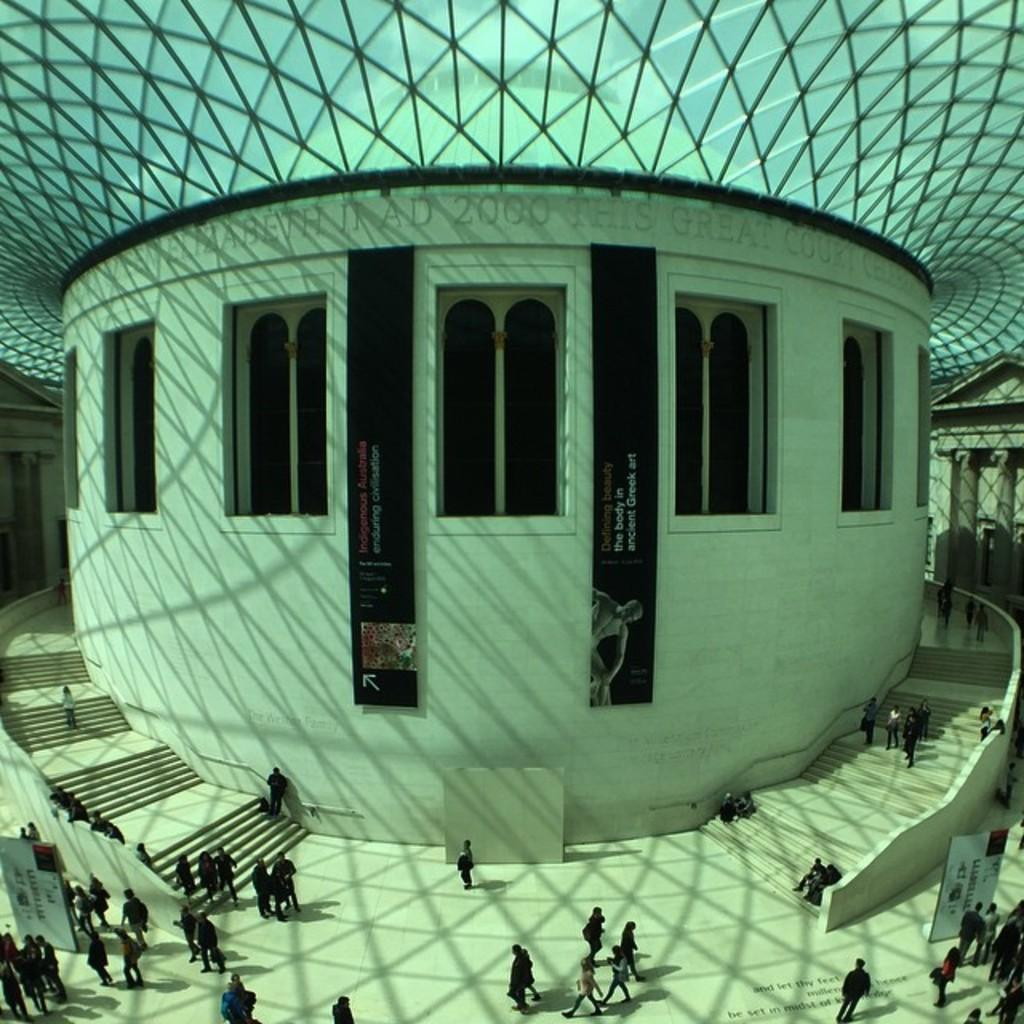What type of structure is visible in the image? There is a building in the image. What can be seen on the path in the image? There are boards on the path in the image. What color are the posters in the image? The posters in the image are black. What is written on the floor in the image? There is text on the floor in the image. How many geese are present in the image? There are no geese present in the image. What type of knowledge can be gained from the word on the floor in the image? There is no word or knowledge mentioned in the image. 